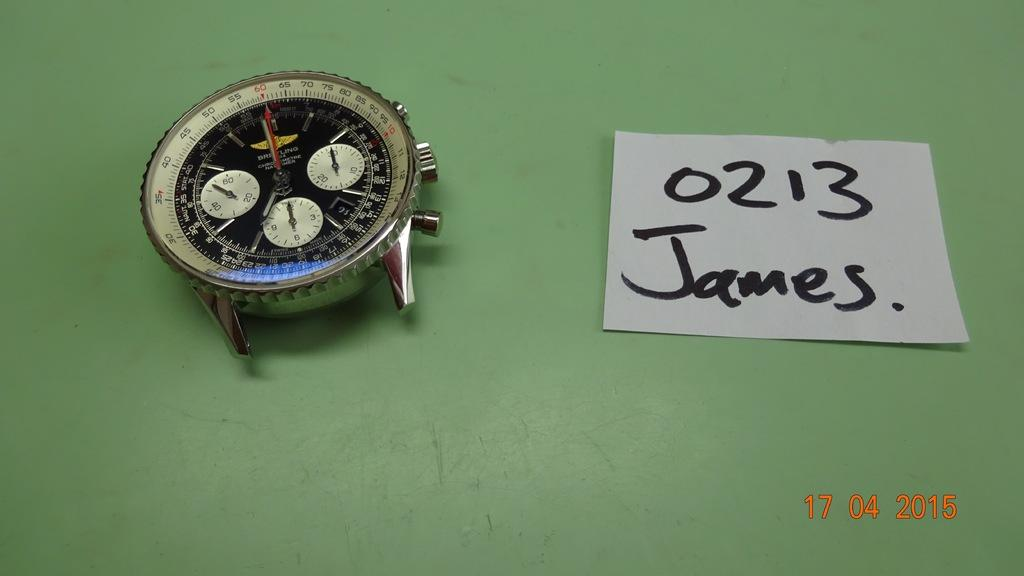<image>
Present a compact description of the photo's key features. A note with "0213 James." is lying on a green table next to old watch face. 